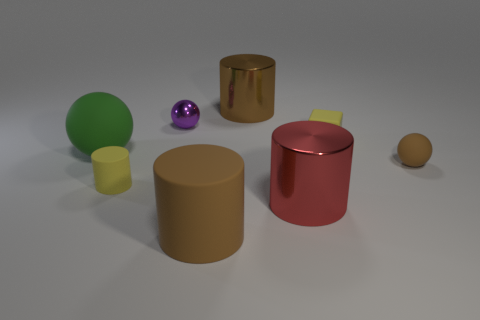Can you describe the texture of the objects in the foreground? Certainly! The objects in the foreground have a smooth and clean appearance without any visible graininess or roughness, indicative of a polished or matte finish. 